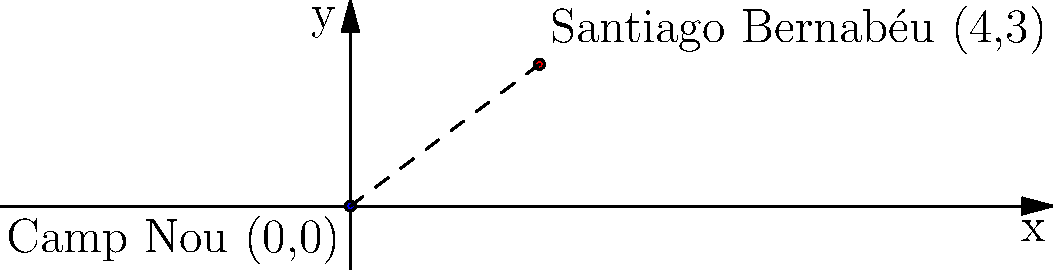In La Liga, Spain's top football league, the Camp Nou stadium (home of FC Barcelona) is located at coordinates (0,0) and the Santiago Bernabéu stadium (home of Real Madrid) is at (4,3) on a coordinate plane where each unit represents 100 km. Calculate the straight-line distance between these two iconic stadiums. To find the distance between two points on a coordinate plane, we can use the distance formula:

$$d = \sqrt{(x_2 - x_1)^2 + (y_2 - y_1)^2}$$

Where $(x_1, y_1)$ is the coordinate of the first point and $(x_2, y_2)$ is the coordinate of the second point.

In this case:
Camp Nou: $(x_1, y_1) = (0, 0)$
Santiago Bernabéu: $(x_2, y_2) = (4, 3)$

Let's plug these values into the formula:

$$d = \sqrt{(4 - 0)^2 + (3 - 0)^2}$$

Simplify:
$$d = \sqrt{4^2 + 3^2}$$
$$d = \sqrt{16 + 9}$$
$$d = \sqrt{25}$$
$$d = 5$$

Since each unit represents 100 km, we multiply the result by 100:

$$5 \times 100 = 500 \text{ km}$$

Therefore, the straight-line distance between Camp Nou and Santiago Bernabéu is 500 km.
Answer: 500 km 